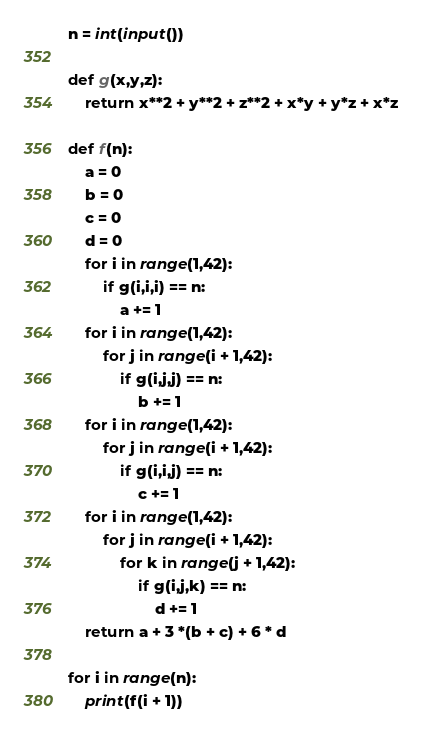Convert code to text. <code><loc_0><loc_0><loc_500><loc_500><_Python_>n = int(input())

def g(x,y,z):
    return x**2 + y**2 + z**2 + x*y + y*z + x*z

def f(n):
    a = 0
    b = 0
    c = 0
    d = 0
    for i in range(1,42):
        if g(i,i,i) == n:
            a += 1
    for i in range(1,42):
        for j in range(i + 1,42):
            if g(i,j,j) == n:
                b += 1
    for i in range(1,42):
        for j in range(i + 1,42):
            if g(i,i,j) == n:
                c += 1
    for i in range(1,42):
        for j in range(i + 1,42):
            for k in range(j + 1,42):
                if g(i,j,k) == n:
                    d += 1
    return a + 3 *(b + c) + 6 * d

for i in range(n):
    print(f(i + 1))
</code> 